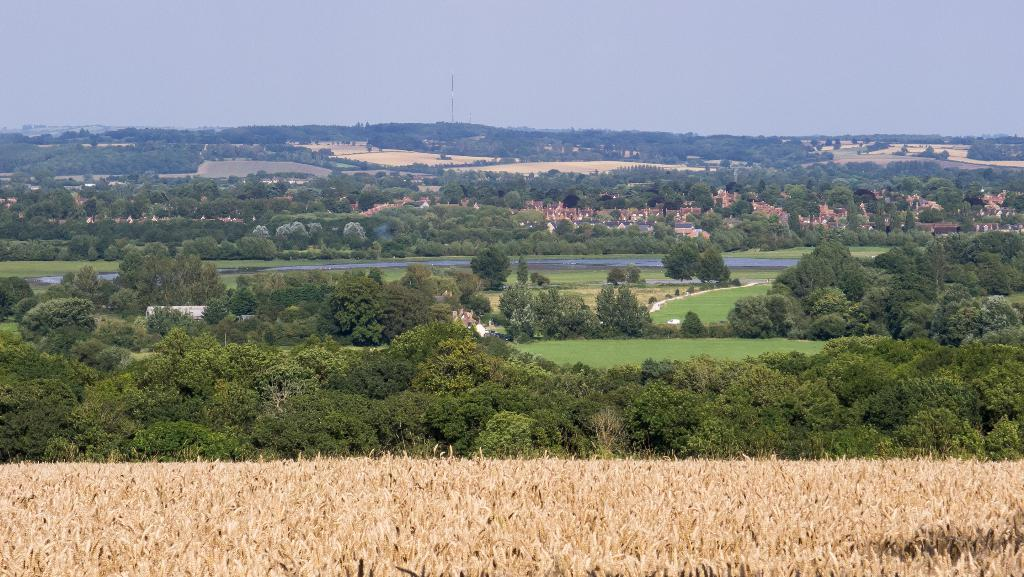What type of vegetation can be seen in the image? There are plants and trees in the image. What natural element is visible in the image? There is water visible in the image. What type of ground cover is present in the image? There is grass in the image. What type of man-made structures are visible in the image? There are buildings in the image. What object is present that might be used for signage or support? There is a pole in the image. What is visible in the background of the image? The sky is visible in the background of the image. What type of pets can be seen playing with a memory foam in the image? There are no pets or memory foam present in the image. What substance is being used to create the buildings in the image? The buildings in the image are made of materials such as concrete, steel, or brick, not a substance mentioned in the provided facts. 